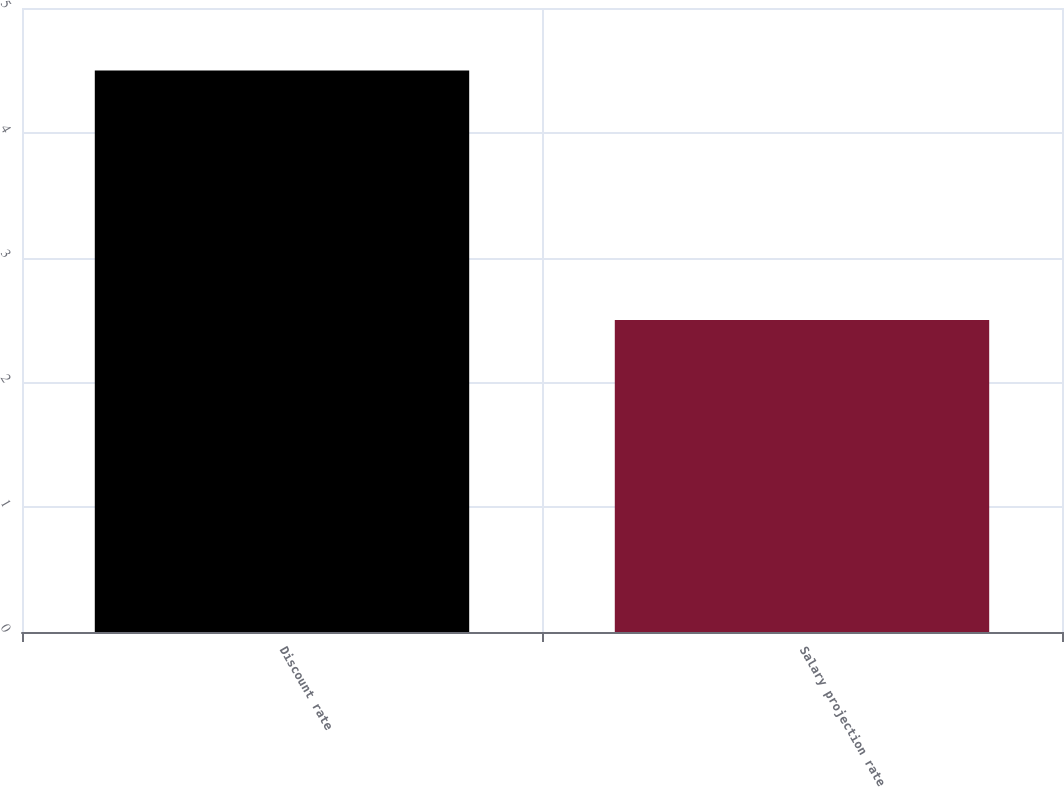Convert chart to OTSL. <chart><loc_0><loc_0><loc_500><loc_500><bar_chart><fcel>Discount rate<fcel>Salary projection rate<nl><fcel>4.5<fcel>2.5<nl></chart> 